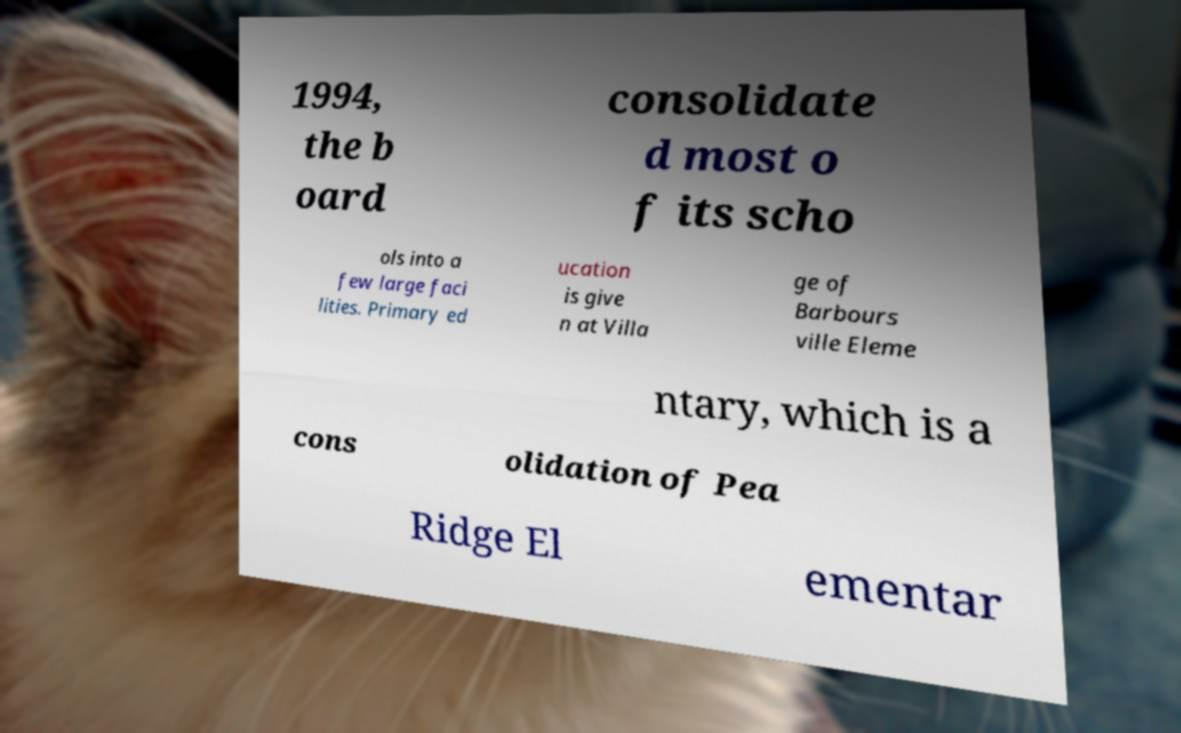Can you read and provide the text displayed in the image?This photo seems to have some interesting text. Can you extract and type it out for me? 1994, the b oard consolidate d most o f its scho ols into a few large faci lities. Primary ed ucation is give n at Villa ge of Barbours ville Eleme ntary, which is a cons olidation of Pea Ridge El ementar 